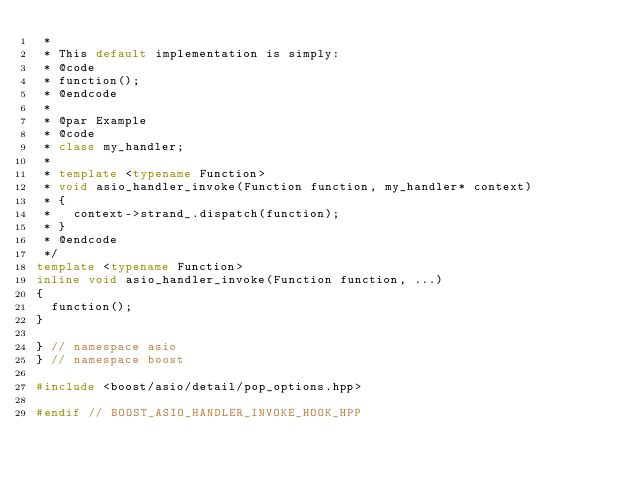<code> <loc_0><loc_0><loc_500><loc_500><_C++_> *
 * This default implementation is simply:
 * @code
 * function();
 * @endcode
 *
 * @par Example
 * @code
 * class my_handler;
 *
 * template <typename Function>
 * void asio_handler_invoke(Function function, my_handler* context)
 * {
 *   context->strand_.dispatch(function);
 * }
 * @endcode
 */
template <typename Function>
inline void asio_handler_invoke(Function function, ...)
{
  function();
}

} // namespace asio
} // namespace boost

#include <boost/asio/detail/pop_options.hpp>

#endif // BOOST_ASIO_HANDLER_INVOKE_HOOK_HPP
</code> 